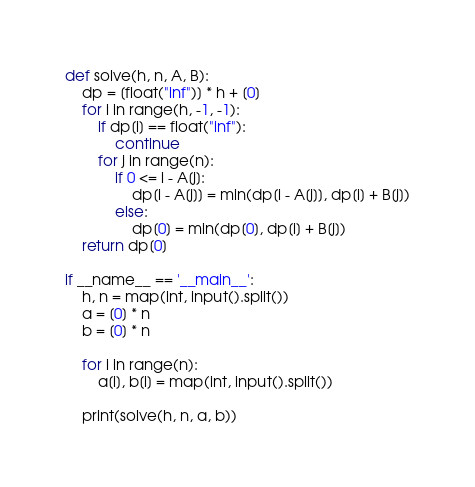Convert code to text. <code><loc_0><loc_0><loc_500><loc_500><_Python_>def solve(h, n, A, B):
    dp = [float("inf")] * h + [0]
    for i in range(h, -1, -1):
        if dp[i] == float("inf"):
            continue
        for j in range(n):
            if 0 <= i - A[j]:
                dp[i - A[j]] = min(dp[i - A[j]], dp[i] + B[j])
            else:
                dp[0] = min(dp[0], dp[i] + B[j])
    return dp[0]

if __name__ == '__main__':
    h, n = map(int, input().split())
    a = [0] * n
    b = [0] * n

    for i in range(n):
        a[i], b[i] = map(int, input().split())

    print(solve(h, n, a, b))</code> 